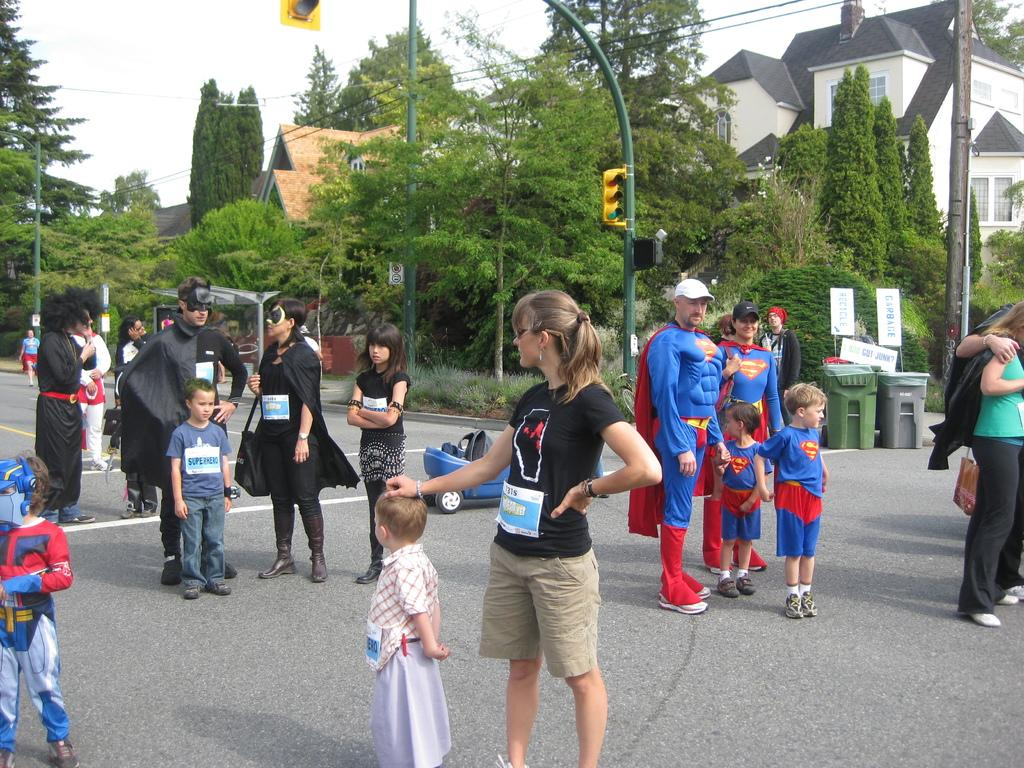What can be seen in the sky in the image? The sky is visible in the image. What type of natural vegetation is present in the image? There are trees in the image. What type of structure is visible in the image? There is a house in the image. What type of traffic control devices are present in the image? Traffic signals are present in the image. What type of vertical structures are visible in the image? Poles are visible in the image. What type of signage is present in the image? Boards are present in the image. What type of waste disposal containers are visible in the image? Trash cans are visible in the image. What type of living organisms are present in the image? People are present in the image. What type of vehicle is visible on the road in the image? There is a blue vehicle on the road in the image. What caption is written on the boards in the image? There is no caption visible on the boards in the image. What type of arm is visible on the blue vehicle in the image? There is no arm visible on the blue vehicle in the image. 